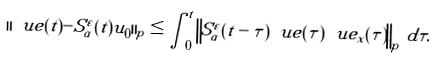<formula> <loc_0><loc_0><loc_500><loc_500>\| \ u e ( t ) - S ^ { \varepsilon } _ { \alpha } ( t ) u _ { 0 } \| _ { p } \leq \int _ { 0 } ^ { t } \left \| S ^ { \varepsilon } _ { \alpha } ( t - \tau ) \ u e ( \tau ) \ u e _ { x } ( \tau ) \right \| _ { p } \, d \tau .</formula> 